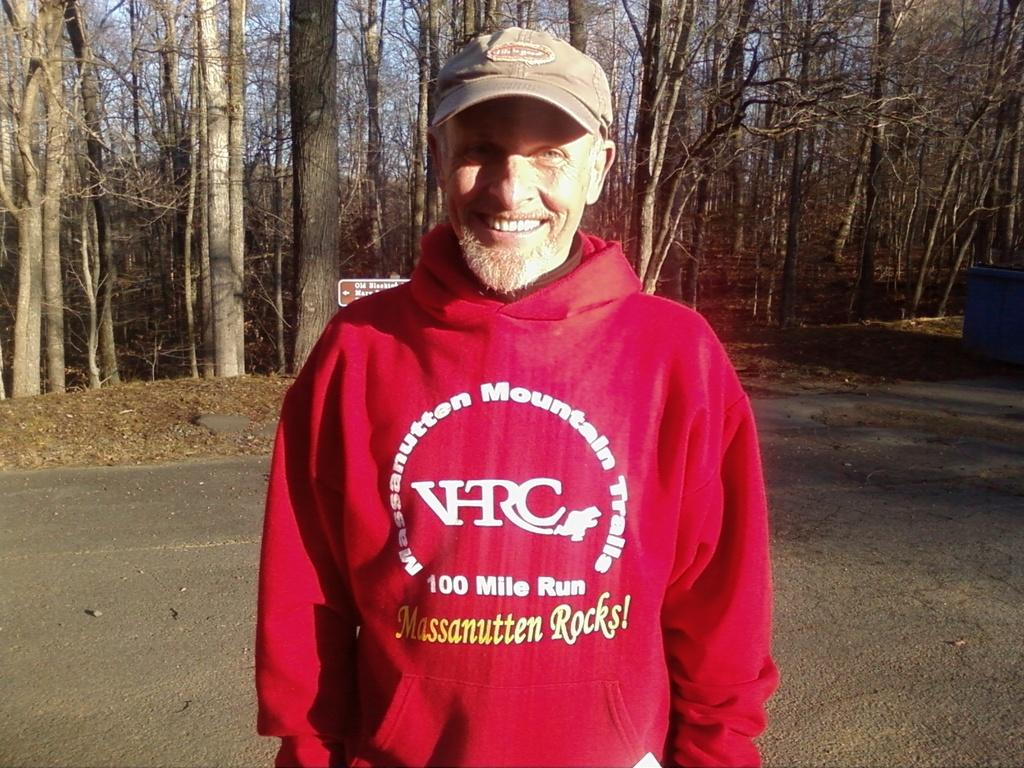Provide a one-sentence caption for the provided image. A man in a red sweater which is the words 100 mile run on it. 